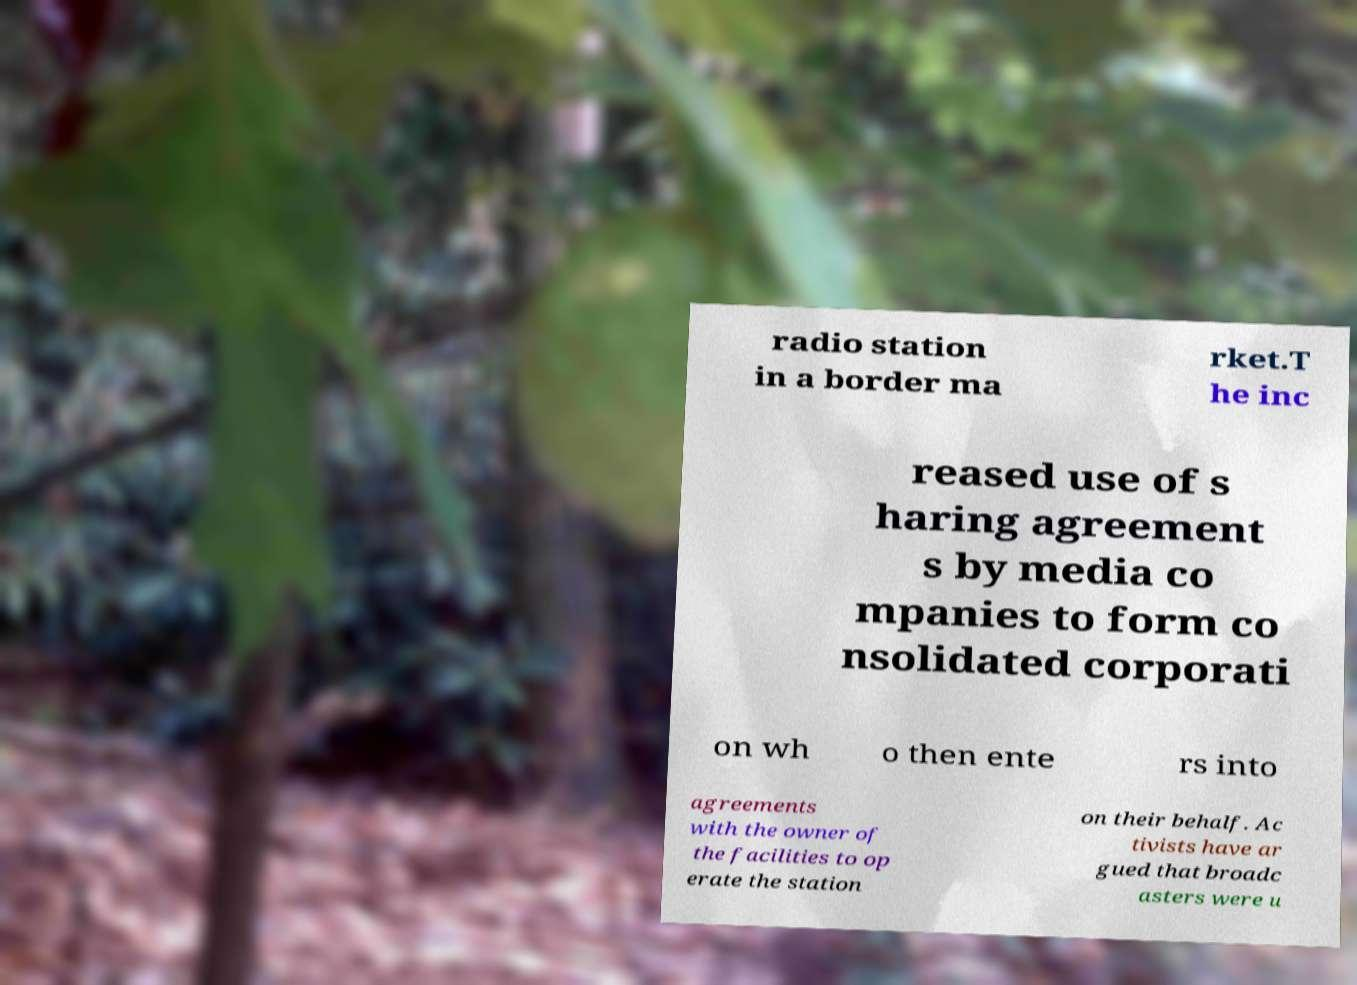Please identify and transcribe the text found in this image. radio station in a border ma rket.T he inc reased use of s haring agreement s by media co mpanies to form co nsolidated corporati on wh o then ente rs into agreements with the owner of the facilities to op erate the station on their behalf. Ac tivists have ar gued that broadc asters were u 